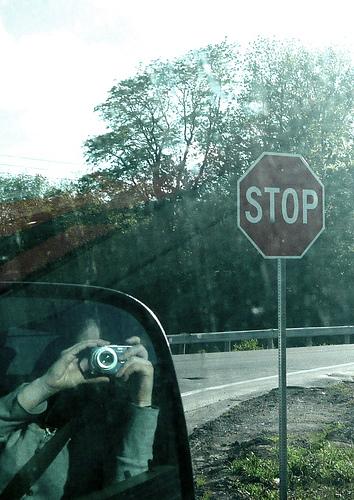Who is holding a camera?
Concise answer only. Passenger. What does the sign say?
Short answer required. Stop. Is the person wearing a seatbelt?
Be succinct. Yes. 